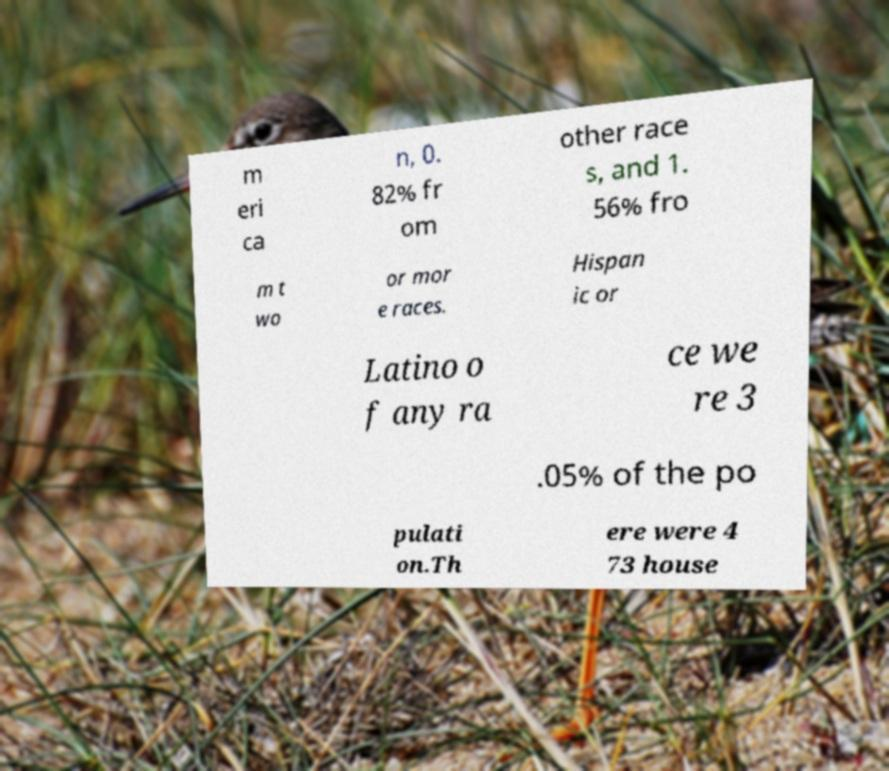Please read and relay the text visible in this image. What does it say? m eri ca n, 0. 82% fr om other race s, and 1. 56% fro m t wo or mor e races. Hispan ic or Latino o f any ra ce we re 3 .05% of the po pulati on.Th ere were 4 73 house 